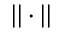<formula> <loc_0><loc_0><loc_500><loc_500>| | \cdot | |</formula> 